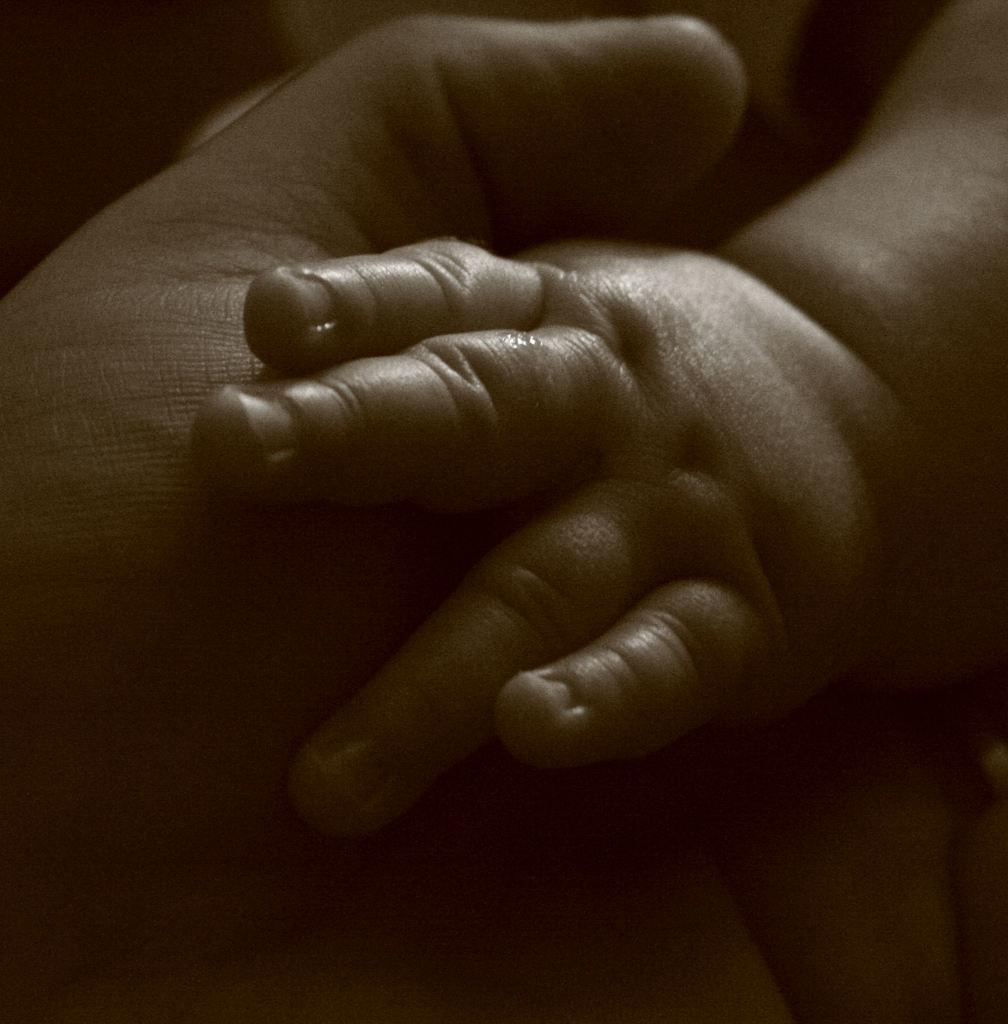What is the main subject of the image? The main subject of the image is hands. Can you describe the position or action of the hands in the image? Unfortunately, the provided facts do not give any information about the position or action of the hands. What type of trucks are being driven by the hands in the image? There are no trucks present in the image; it only features hands. 